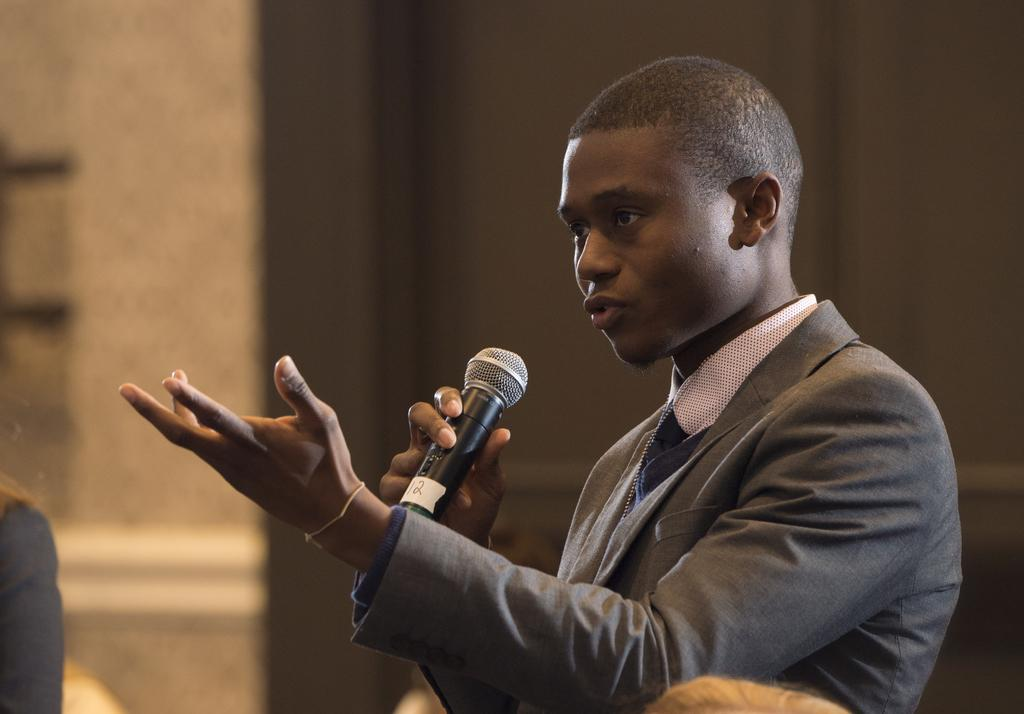Who is the main subject in the image? There is a man in the image. What is the man wearing? The man is wearing a blazer. What is the man holding in the image? The man is holding a microphone. What is the man doing in the image? The man is talking. What can be seen in the background of the image? There is a wall in the background of the image. What verse is the laborer reciting in the image? There is no laborer present in the image, and no verse is being recited. 